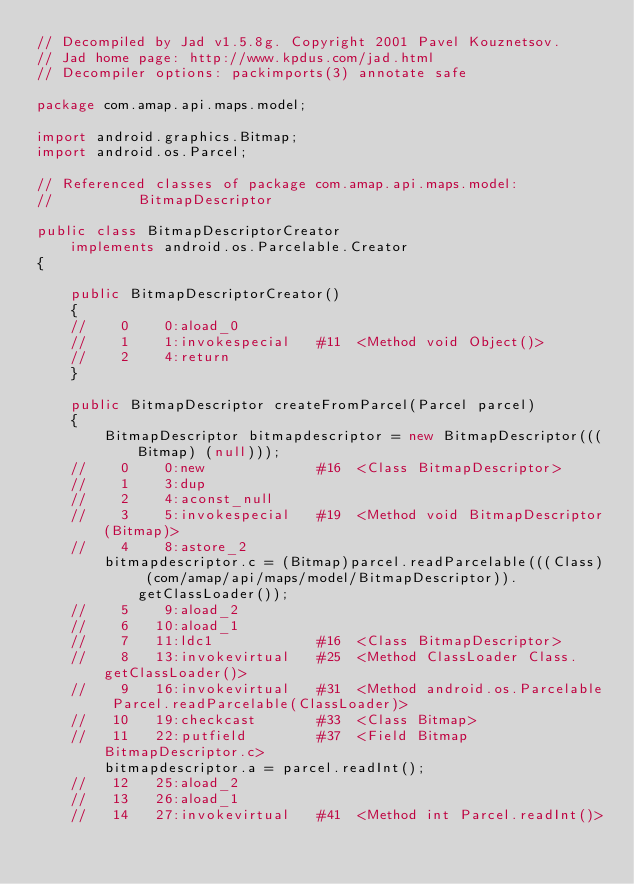<code> <loc_0><loc_0><loc_500><loc_500><_Java_>// Decompiled by Jad v1.5.8g. Copyright 2001 Pavel Kouznetsov.
// Jad home page: http://www.kpdus.com/jad.html
// Decompiler options: packimports(3) annotate safe 

package com.amap.api.maps.model;

import android.graphics.Bitmap;
import android.os.Parcel;

// Referenced classes of package com.amap.api.maps.model:
//			BitmapDescriptor

public class BitmapDescriptorCreator
	implements android.os.Parcelable.Creator
{

	public BitmapDescriptorCreator()
	{
	//    0    0:aload_0         
	//    1    1:invokespecial   #11  <Method void Object()>
	//    2    4:return          
	}

	public BitmapDescriptor createFromParcel(Parcel parcel)
	{
		BitmapDescriptor bitmapdescriptor = new BitmapDescriptor(((Bitmap) (null)));
	//    0    0:new             #16  <Class BitmapDescriptor>
	//    1    3:dup             
	//    2    4:aconst_null     
	//    3    5:invokespecial   #19  <Method void BitmapDescriptor(Bitmap)>
	//    4    8:astore_2        
		bitmapdescriptor.c = (Bitmap)parcel.readParcelable(((Class) (com/amap/api/maps/model/BitmapDescriptor)).getClassLoader());
	//    5    9:aload_2         
	//    6   10:aload_1         
	//    7   11:ldc1            #16  <Class BitmapDescriptor>
	//    8   13:invokevirtual   #25  <Method ClassLoader Class.getClassLoader()>
	//    9   16:invokevirtual   #31  <Method android.os.Parcelable Parcel.readParcelable(ClassLoader)>
	//   10   19:checkcast       #33  <Class Bitmap>
	//   11   22:putfield        #37  <Field Bitmap BitmapDescriptor.c>
		bitmapdescriptor.a = parcel.readInt();
	//   12   25:aload_2         
	//   13   26:aload_1         
	//   14   27:invokevirtual   #41  <Method int Parcel.readInt()></code> 